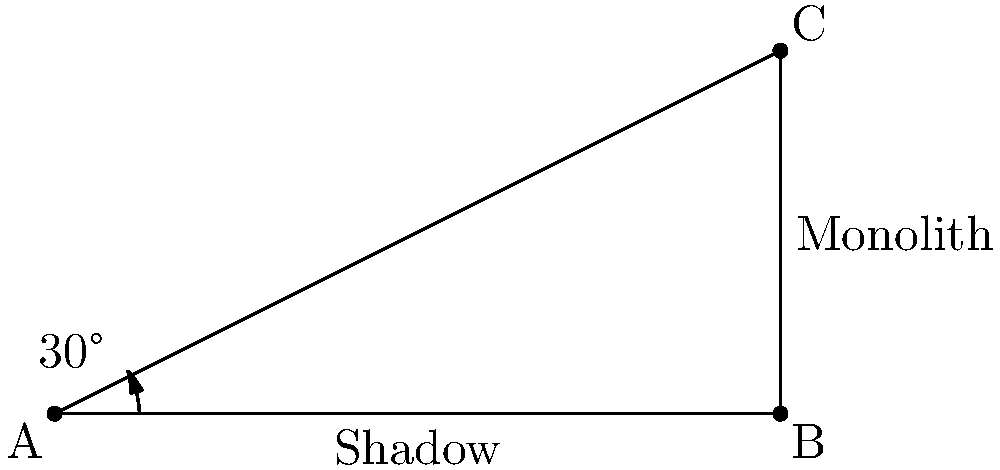On the alien world of Arrakis, a mysterious monolith casts a shadow in the light of the binary suns. If the angle of elevation of the suns is $30°$ and the shadow extends $6$ units from the base of the monolith, what is the height of the monolith to the nearest tenth of a unit? Let's approach this step-by-step:

1) In this scenario, we have a right-angled triangle. The shadow forms the base, the monolith forms the height, and the line from the top of the monolith to the end of the shadow forms the hypotenuse.

2) We know the angle of elevation (which is the same as the angle formed at the base of the triangle) is $30°$.

3) We also know the length of the shadow, which is 6 units. This forms the adjacent side to our known angle.

4) To find the height of the monolith, we need to use the tangent ratio. The tangent of an angle in a right-angled triangle is the ratio of the opposite side to the adjacent side.

5) In this case:
   $\tan(30°) = \frac{\text{height of monolith}}{\text{length of shadow}}$

6) We can express this as an equation:
   $\tan(30°) = \frac{h}{6}$, where $h$ is the height of the monolith.

7) To solve for $h$, we multiply both sides by 6:
   $6 \tan(30°) = h$

8) Now, we need to calculate this:
   $h = 6 \times \tan(30°)$
   $h = 6 \times 0.5773... \approx 3.4641...$

9) Rounding to the nearest tenth:
   $h \approx 3.5$ units

Therefore, the height of the monolith is approximately 3.5 units.
Answer: $3.5$ units 